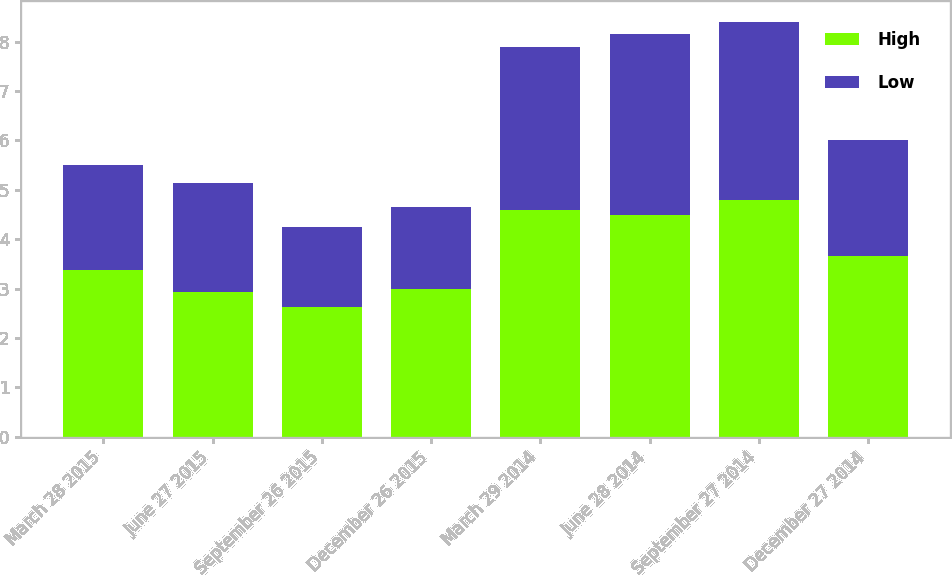Convert chart to OTSL. <chart><loc_0><loc_0><loc_500><loc_500><stacked_bar_chart><ecel><fcel>March 28 2015<fcel>June 27 2015<fcel>September 26 2015<fcel>December 26 2015<fcel>March 29 2014<fcel>June 28 2014<fcel>September 27 2014<fcel>December 27 2014<nl><fcel>High<fcel>3.37<fcel>2.94<fcel>2.63<fcel>3<fcel>4.6<fcel>4.5<fcel>4.8<fcel>3.66<nl><fcel>Low<fcel>2.14<fcel>2.2<fcel>1.61<fcel>1.65<fcel>3.29<fcel>3.65<fcel>3.6<fcel>2.35<nl></chart> 